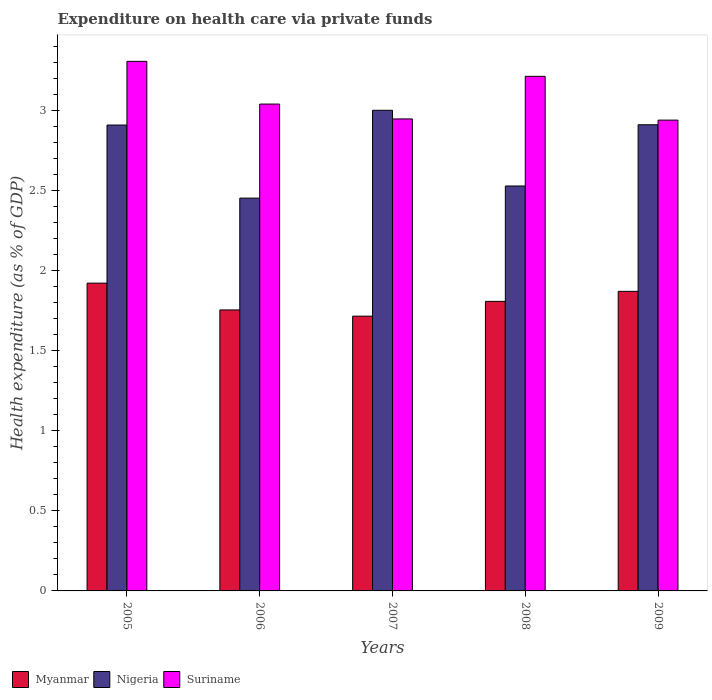How many different coloured bars are there?
Your response must be concise. 3. How many groups of bars are there?
Offer a very short reply. 5. Are the number of bars per tick equal to the number of legend labels?
Your answer should be very brief. Yes. Are the number of bars on each tick of the X-axis equal?
Your answer should be compact. Yes. How many bars are there on the 5th tick from the left?
Give a very brief answer. 3. What is the expenditure made on health care in Suriname in 2005?
Provide a short and direct response. 3.31. Across all years, what is the maximum expenditure made on health care in Nigeria?
Give a very brief answer. 3. Across all years, what is the minimum expenditure made on health care in Nigeria?
Keep it short and to the point. 2.45. What is the total expenditure made on health care in Nigeria in the graph?
Make the answer very short. 13.8. What is the difference between the expenditure made on health care in Suriname in 2008 and that in 2009?
Your answer should be very brief. 0.27. What is the difference between the expenditure made on health care in Suriname in 2008 and the expenditure made on health care in Myanmar in 2005?
Keep it short and to the point. 1.29. What is the average expenditure made on health care in Nigeria per year?
Offer a very short reply. 2.76. In the year 2009, what is the difference between the expenditure made on health care in Nigeria and expenditure made on health care in Myanmar?
Provide a succinct answer. 1.04. In how many years, is the expenditure made on health care in Myanmar greater than 0.30000000000000004 %?
Your answer should be compact. 5. What is the ratio of the expenditure made on health care in Myanmar in 2006 to that in 2009?
Ensure brevity in your answer.  0.94. Is the expenditure made on health care in Nigeria in 2005 less than that in 2009?
Your answer should be compact. Yes. What is the difference between the highest and the second highest expenditure made on health care in Myanmar?
Your response must be concise. 0.05. What is the difference between the highest and the lowest expenditure made on health care in Nigeria?
Provide a succinct answer. 0.55. What does the 1st bar from the left in 2005 represents?
Provide a succinct answer. Myanmar. What does the 3rd bar from the right in 2008 represents?
Provide a short and direct response. Myanmar. How many bars are there?
Your answer should be compact. 15. What is the difference between two consecutive major ticks on the Y-axis?
Your answer should be compact. 0.5. Does the graph contain grids?
Ensure brevity in your answer.  No. Where does the legend appear in the graph?
Make the answer very short. Bottom left. How many legend labels are there?
Provide a succinct answer. 3. What is the title of the graph?
Keep it short and to the point. Expenditure on health care via private funds. Does "Slovenia" appear as one of the legend labels in the graph?
Offer a very short reply. No. What is the label or title of the Y-axis?
Your response must be concise. Health expenditure (as % of GDP). What is the Health expenditure (as % of GDP) of Myanmar in 2005?
Provide a succinct answer. 1.92. What is the Health expenditure (as % of GDP) of Nigeria in 2005?
Keep it short and to the point. 2.91. What is the Health expenditure (as % of GDP) in Suriname in 2005?
Ensure brevity in your answer.  3.31. What is the Health expenditure (as % of GDP) of Myanmar in 2006?
Your response must be concise. 1.75. What is the Health expenditure (as % of GDP) in Nigeria in 2006?
Your response must be concise. 2.45. What is the Health expenditure (as % of GDP) of Suriname in 2006?
Keep it short and to the point. 3.04. What is the Health expenditure (as % of GDP) in Myanmar in 2007?
Ensure brevity in your answer.  1.72. What is the Health expenditure (as % of GDP) of Nigeria in 2007?
Ensure brevity in your answer.  3. What is the Health expenditure (as % of GDP) of Suriname in 2007?
Your answer should be very brief. 2.95. What is the Health expenditure (as % of GDP) in Myanmar in 2008?
Provide a short and direct response. 1.81. What is the Health expenditure (as % of GDP) of Nigeria in 2008?
Your answer should be compact. 2.53. What is the Health expenditure (as % of GDP) in Suriname in 2008?
Ensure brevity in your answer.  3.21. What is the Health expenditure (as % of GDP) of Myanmar in 2009?
Provide a succinct answer. 1.87. What is the Health expenditure (as % of GDP) of Nigeria in 2009?
Keep it short and to the point. 2.91. What is the Health expenditure (as % of GDP) in Suriname in 2009?
Offer a terse response. 2.94. Across all years, what is the maximum Health expenditure (as % of GDP) in Myanmar?
Give a very brief answer. 1.92. Across all years, what is the maximum Health expenditure (as % of GDP) of Nigeria?
Offer a very short reply. 3. Across all years, what is the maximum Health expenditure (as % of GDP) of Suriname?
Provide a succinct answer. 3.31. Across all years, what is the minimum Health expenditure (as % of GDP) in Myanmar?
Provide a succinct answer. 1.72. Across all years, what is the minimum Health expenditure (as % of GDP) in Nigeria?
Offer a very short reply. 2.45. Across all years, what is the minimum Health expenditure (as % of GDP) of Suriname?
Offer a very short reply. 2.94. What is the total Health expenditure (as % of GDP) in Myanmar in the graph?
Make the answer very short. 9.07. What is the total Health expenditure (as % of GDP) of Nigeria in the graph?
Ensure brevity in your answer.  13.8. What is the total Health expenditure (as % of GDP) in Suriname in the graph?
Your answer should be compact. 15.44. What is the difference between the Health expenditure (as % of GDP) of Myanmar in 2005 and that in 2006?
Your answer should be compact. 0.17. What is the difference between the Health expenditure (as % of GDP) of Nigeria in 2005 and that in 2006?
Give a very brief answer. 0.46. What is the difference between the Health expenditure (as % of GDP) in Suriname in 2005 and that in 2006?
Give a very brief answer. 0.27. What is the difference between the Health expenditure (as % of GDP) in Myanmar in 2005 and that in 2007?
Provide a short and direct response. 0.21. What is the difference between the Health expenditure (as % of GDP) in Nigeria in 2005 and that in 2007?
Your response must be concise. -0.09. What is the difference between the Health expenditure (as % of GDP) of Suriname in 2005 and that in 2007?
Provide a succinct answer. 0.36. What is the difference between the Health expenditure (as % of GDP) in Myanmar in 2005 and that in 2008?
Your response must be concise. 0.11. What is the difference between the Health expenditure (as % of GDP) of Nigeria in 2005 and that in 2008?
Keep it short and to the point. 0.38. What is the difference between the Health expenditure (as % of GDP) in Suriname in 2005 and that in 2008?
Make the answer very short. 0.09. What is the difference between the Health expenditure (as % of GDP) of Myanmar in 2005 and that in 2009?
Offer a very short reply. 0.05. What is the difference between the Health expenditure (as % of GDP) of Nigeria in 2005 and that in 2009?
Provide a short and direct response. -0. What is the difference between the Health expenditure (as % of GDP) of Suriname in 2005 and that in 2009?
Make the answer very short. 0.37. What is the difference between the Health expenditure (as % of GDP) in Myanmar in 2006 and that in 2007?
Provide a short and direct response. 0.04. What is the difference between the Health expenditure (as % of GDP) of Nigeria in 2006 and that in 2007?
Give a very brief answer. -0.55. What is the difference between the Health expenditure (as % of GDP) in Suriname in 2006 and that in 2007?
Provide a succinct answer. 0.09. What is the difference between the Health expenditure (as % of GDP) in Myanmar in 2006 and that in 2008?
Provide a short and direct response. -0.05. What is the difference between the Health expenditure (as % of GDP) of Nigeria in 2006 and that in 2008?
Offer a terse response. -0.08. What is the difference between the Health expenditure (as % of GDP) in Suriname in 2006 and that in 2008?
Provide a succinct answer. -0.17. What is the difference between the Health expenditure (as % of GDP) of Myanmar in 2006 and that in 2009?
Ensure brevity in your answer.  -0.12. What is the difference between the Health expenditure (as % of GDP) of Nigeria in 2006 and that in 2009?
Keep it short and to the point. -0.46. What is the difference between the Health expenditure (as % of GDP) in Suriname in 2006 and that in 2009?
Offer a very short reply. 0.1. What is the difference between the Health expenditure (as % of GDP) of Myanmar in 2007 and that in 2008?
Provide a short and direct response. -0.09. What is the difference between the Health expenditure (as % of GDP) of Nigeria in 2007 and that in 2008?
Offer a very short reply. 0.47. What is the difference between the Health expenditure (as % of GDP) of Suriname in 2007 and that in 2008?
Your response must be concise. -0.27. What is the difference between the Health expenditure (as % of GDP) of Myanmar in 2007 and that in 2009?
Ensure brevity in your answer.  -0.15. What is the difference between the Health expenditure (as % of GDP) in Nigeria in 2007 and that in 2009?
Keep it short and to the point. 0.09. What is the difference between the Health expenditure (as % of GDP) of Suriname in 2007 and that in 2009?
Offer a very short reply. 0.01. What is the difference between the Health expenditure (as % of GDP) in Myanmar in 2008 and that in 2009?
Make the answer very short. -0.06. What is the difference between the Health expenditure (as % of GDP) of Nigeria in 2008 and that in 2009?
Offer a terse response. -0.38. What is the difference between the Health expenditure (as % of GDP) in Suriname in 2008 and that in 2009?
Make the answer very short. 0.27. What is the difference between the Health expenditure (as % of GDP) in Myanmar in 2005 and the Health expenditure (as % of GDP) in Nigeria in 2006?
Make the answer very short. -0.53. What is the difference between the Health expenditure (as % of GDP) in Myanmar in 2005 and the Health expenditure (as % of GDP) in Suriname in 2006?
Provide a short and direct response. -1.12. What is the difference between the Health expenditure (as % of GDP) in Nigeria in 2005 and the Health expenditure (as % of GDP) in Suriname in 2006?
Provide a short and direct response. -0.13. What is the difference between the Health expenditure (as % of GDP) of Myanmar in 2005 and the Health expenditure (as % of GDP) of Nigeria in 2007?
Provide a short and direct response. -1.08. What is the difference between the Health expenditure (as % of GDP) in Myanmar in 2005 and the Health expenditure (as % of GDP) in Suriname in 2007?
Offer a terse response. -1.03. What is the difference between the Health expenditure (as % of GDP) in Nigeria in 2005 and the Health expenditure (as % of GDP) in Suriname in 2007?
Provide a succinct answer. -0.04. What is the difference between the Health expenditure (as % of GDP) in Myanmar in 2005 and the Health expenditure (as % of GDP) in Nigeria in 2008?
Ensure brevity in your answer.  -0.61. What is the difference between the Health expenditure (as % of GDP) in Myanmar in 2005 and the Health expenditure (as % of GDP) in Suriname in 2008?
Keep it short and to the point. -1.29. What is the difference between the Health expenditure (as % of GDP) of Nigeria in 2005 and the Health expenditure (as % of GDP) of Suriname in 2008?
Provide a short and direct response. -0.3. What is the difference between the Health expenditure (as % of GDP) of Myanmar in 2005 and the Health expenditure (as % of GDP) of Nigeria in 2009?
Offer a very short reply. -0.99. What is the difference between the Health expenditure (as % of GDP) of Myanmar in 2005 and the Health expenditure (as % of GDP) of Suriname in 2009?
Offer a very short reply. -1.02. What is the difference between the Health expenditure (as % of GDP) in Nigeria in 2005 and the Health expenditure (as % of GDP) in Suriname in 2009?
Provide a short and direct response. -0.03. What is the difference between the Health expenditure (as % of GDP) in Myanmar in 2006 and the Health expenditure (as % of GDP) in Nigeria in 2007?
Provide a short and direct response. -1.25. What is the difference between the Health expenditure (as % of GDP) of Myanmar in 2006 and the Health expenditure (as % of GDP) of Suriname in 2007?
Give a very brief answer. -1.19. What is the difference between the Health expenditure (as % of GDP) in Nigeria in 2006 and the Health expenditure (as % of GDP) in Suriname in 2007?
Provide a short and direct response. -0.49. What is the difference between the Health expenditure (as % of GDP) of Myanmar in 2006 and the Health expenditure (as % of GDP) of Nigeria in 2008?
Provide a short and direct response. -0.77. What is the difference between the Health expenditure (as % of GDP) in Myanmar in 2006 and the Health expenditure (as % of GDP) in Suriname in 2008?
Your answer should be compact. -1.46. What is the difference between the Health expenditure (as % of GDP) in Nigeria in 2006 and the Health expenditure (as % of GDP) in Suriname in 2008?
Give a very brief answer. -0.76. What is the difference between the Health expenditure (as % of GDP) in Myanmar in 2006 and the Health expenditure (as % of GDP) in Nigeria in 2009?
Offer a terse response. -1.16. What is the difference between the Health expenditure (as % of GDP) in Myanmar in 2006 and the Health expenditure (as % of GDP) in Suriname in 2009?
Ensure brevity in your answer.  -1.19. What is the difference between the Health expenditure (as % of GDP) in Nigeria in 2006 and the Health expenditure (as % of GDP) in Suriname in 2009?
Your answer should be compact. -0.49. What is the difference between the Health expenditure (as % of GDP) of Myanmar in 2007 and the Health expenditure (as % of GDP) of Nigeria in 2008?
Keep it short and to the point. -0.81. What is the difference between the Health expenditure (as % of GDP) of Myanmar in 2007 and the Health expenditure (as % of GDP) of Suriname in 2008?
Provide a succinct answer. -1.5. What is the difference between the Health expenditure (as % of GDP) in Nigeria in 2007 and the Health expenditure (as % of GDP) in Suriname in 2008?
Ensure brevity in your answer.  -0.21. What is the difference between the Health expenditure (as % of GDP) in Myanmar in 2007 and the Health expenditure (as % of GDP) in Nigeria in 2009?
Your answer should be very brief. -1.2. What is the difference between the Health expenditure (as % of GDP) in Myanmar in 2007 and the Health expenditure (as % of GDP) in Suriname in 2009?
Offer a very short reply. -1.22. What is the difference between the Health expenditure (as % of GDP) of Nigeria in 2007 and the Health expenditure (as % of GDP) of Suriname in 2009?
Your answer should be very brief. 0.06. What is the difference between the Health expenditure (as % of GDP) in Myanmar in 2008 and the Health expenditure (as % of GDP) in Nigeria in 2009?
Make the answer very short. -1.1. What is the difference between the Health expenditure (as % of GDP) of Myanmar in 2008 and the Health expenditure (as % of GDP) of Suriname in 2009?
Give a very brief answer. -1.13. What is the difference between the Health expenditure (as % of GDP) in Nigeria in 2008 and the Health expenditure (as % of GDP) in Suriname in 2009?
Your answer should be very brief. -0.41. What is the average Health expenditure (as % of GDP) of Myanmar per year?
Give a very brief answer. 1.81. What is the average Health expenditure (as % of GDP) in Nigeria per year?
Your response must be concise. 2.76. What is the average Health expenditure (as % of GDP) in Suriname per year?
Give a very brief answer. 3.09. In the year 2005, what is the difference between the Health expenditure (as % of GDP) in Myanmar and Health expenditure (as % of GDP) in Nigeria?
Keep it short and to the point. -0.99. In the year 2005, what is the difference between the Health expenditure (as % of GDP) in Myanmar and Health expenditure (as % of GDP) in Suriname?
Offer a very short reply. -1.38. In the year 2005, what is the difference between the Health expenditure (as % of GDP) of Nigeria and Health expenditure (as % of GDP) of Suriname?
Your response must be concise. -0.4. In the year 2006, what is the difference between the Health expenditure (as % of GDP) of Myanmar and Health expenditure (as % of GDP) of Nigeria?
Offer a very short reply. -0.7. In the year 2006, what is the difference between the Health expenditure (as % of GDP) of Myanmar and Health expenditure (as % of GDP) of Suriname?
Provide a short and direct response. -1.29. In the year 2006, what is the difference between the Health expenditure (as % of GDP) in Nigeria and Health expenditure (as % of GDP) in Suriname?
Ensure brevity in your answer.  -0.59. In the year 2007, what is the difference between the Health expenditure (as % of GDP) in Myanmar and Health expenditure (as % of GDP) in Nigeria?
Your answer should be very brief. -1.29. In the year 2007, what is the difference between the Health expenditure (as % of GDP) of Myanmar and Health expenditure (as % of GDP) of Suriname?
Offer a terse response. -1.23. In the year 2007, what is the difference between the Health expenditure (as % of GDP) of Nigeria and Health expenditure (as % of GDP) of Suriname?
Keep it short and to the point. 0.05. In the year 2008, what is the difference between the Health expenditure (as % of GDP) in Myanmar and Health expenditure (as % of GDP) in Nigeria?
Your answer should be very brief. -0.72. In the year 2008, what is the difference between the Health expenditure (as % of GDP) of Myanmar and Health expenditure (as % of GDP) of Suriname?
Ensure brevity in your answer.  -1.4. In the year 2008, what is the difference between the Health expenditure (as % of GDP) in Nigeria and Health expenditure (as % of GDP) in Suriname?
Keep it short and to the point. -0.68. In the year 2009, what is the difference between the Health expenditure (as % of GDP) of Myanmar and Health expenditure (as % of GDP) of Nigeria?
Your response must be concise. -1.04. In the year 2009, what is the difference between the Health expenditure (as % of GDP) in Myanmar and Health expenditure (as % of GDP) in Suriname?
Offer a very short reply. -1.07. In the year 2009, what is the difference between the Health expenditure (as % of GDP) of Nigeria and Health expenditure (as % of GDP) of Suriname?
Ensure brevity in your answer.  -0.03. What is the ratio of the Health expenditure (as % of GDP) of Myanmar in 2005 to that in 2006?
Your response must be concise. 1.1. What is the ratio of the Health expenditure (as % of GDP) of Nigeria in 2005 to that in 2006?
Offer a very short reply. 1.19. What is the ratio of the Health expenditure (as % of GDP) in Suriname in 2005 to that in 2006?
Offer a very short reply. 1.09. What is the ratio of the Health expenditure (as % of GDP) in Myanmar in 2005 to that in 2007?
Give a very brief answer. 1.12. What is the ratio of the Health expenditure (as % of GDP) of Nigeria in 2005 to that in 2007?
Offer a terse response. 0.97. What is the ratio of the Health expenditure (as % of GDP) in Suriname in 2005 to that in 2007?
Make the answer very short. 1.12. What is the ratio of the Health expenditure (as % of GDP) in Myanmar in 2005 to that in 2008?
Your answer should be compact. 1.06. What is the ratio of the Health expenditure (as % of GDP) in Nigeria in 2005 to that in 2008?
Give a very brief answer. 1.15. What is the ratio of the Health expenditure (as % of GDP) of Suriname in 2005 to that in 2008?
Offer a very short reply. 1.03. What is the ratio of the Health expenditure (as % of GDP) of Myanmar in 2005 to that in 2009?
Your answer should be compact. 1.03. What is the ratio of the Health expenditure (as % of GDP) of Suriname in 2005 to that in 2009?
Offer a very short reply. 1.12. What is the ratio of the Health expenditure (as % of GDP) in Myanmar in 2006 to that in 2007?
Offer a very short reply. 1.02. What is the ratio of the Health expenditure (as % of GDP) in Nigeria in 2006 to that in 2007?
Provide a succinct answer. 0.82. What is the ratio of the Health expenditure (as % of GDP) in Suriname in 2006 to that in 2007?
Your response must be concise. 1.03. What is the ratio of the Health expenditure (as % of GDP) in Myanmar in 2006 to that in 2008?
Offer a terse response. 0.97. What is the ratio of the Health expenditure (as % of GDP) in Suriname in 2006 to that in 2008?
Your answer should be very brief. 0.95. What is the ratio of the Health expenditure (as % of GDP) in Myanmar in 2006 to that in 2009?
Give a very brief answer. 0.94. What is the ratio of the Health expenditure (as % of GDP) in Nigeria in 2006 to that in 2009?
Your answer should be very brief. 0.84. What is the ratio of the Health expenditure (as % of GDP) of Suriname in 2006 to that in 2009?
Your response must be concise. 1.03. What is the ratio of the Health expenditure (as % of GDP) in Myanmar in 2007 to that in 2008?
Your response must be concise. 0.95. What is the ratio of the Health expenditure (as % of GDP) of Nigeria in 2007 to that in 2008?
Your answer should be very brief. 1.19. What is the ratio of the Health expenditure (as % of GDP) in Suriname in 2007 to that in 2008?
Your answer should be very brief. 0.92. What is the ratio of the Health expenditure (as % of GDP) in Myanmar in 2007 to that in 2009?
Keep it short and to the point. 0.92. What is the ratio of the Health expenditure (as % of GDP) in Nigeria in 2007 to that in 2009?
Ensure brevity in your answer.  1.03. What is the ratio of the Health expenditure (as % of GDP) of Suriname in 2007 to that in 2009?
Your answer should be very brief. 1. What is the ratio of the Health expenditure (as % of GDP) of Myanmar in 2008 to that in 2009?
Give a very brief answer. 0.97. What is the ratio of the Health expenditure (as % of GDP) of Nigeria in 2008 to that in 2009?
Keep it short and to the point. 0.87. What is the ratio of the Health expenditure (as % of GDP) of Suriname in 2008 to that in 2009?
Provide a short and direct response. 1.09. What is the difference between the highest and the second highest Health expenditure (as % of GDP) in Myanmar?
Your response must be concise. 0.05. What is the difference between the highest and the second highest Health expenditure (as % of GDP) of Nigeria?
Your answer should be compact. 0.09. What is the difference between the highest and the second highest Health expenditure (as % of GDP) of Suriname?
Provide a short and direct response. 0.09. What is the difference between the highest and the lowest Health expenditure (as % of GDP) in Myanmar?
Give a very brief answer. 0.21. What is the difference between the highest and the lowest Health expenditure (as % of GDP) of Nigeria?
Your answer should be very brief. 0.55. What is the difference between the highest and the lowest Health expenditure (as % of GDP) of Suriname?
Your answer should be compact. 0.37. 